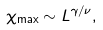Convert formula to latex. <formula><loc_0><loc_0><loc_500><loc_500>\chi _ { \max } \sim L ^ { \gamma / \nu } ,</formula> 